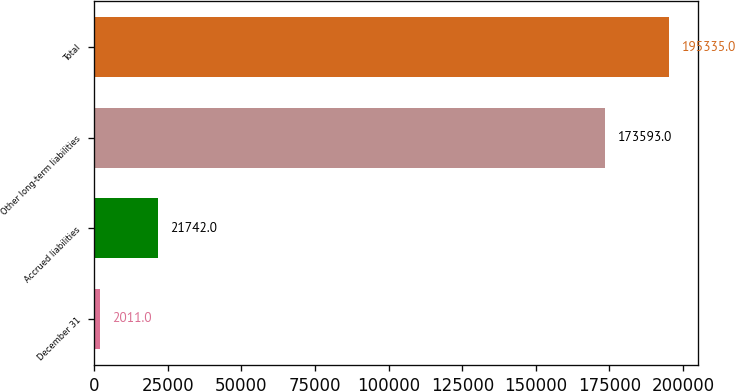Convert chart. <chart><loc_0><loc_0><loc_500><loc_500><bar_chart><fcel>December 31<fcel>Accrued liabilities<fcel>Other long-term liabilities<fcel>Total<nl><fcel>2011<fcel>21742<fcel>173593<fcel>195335<nl></chart> 